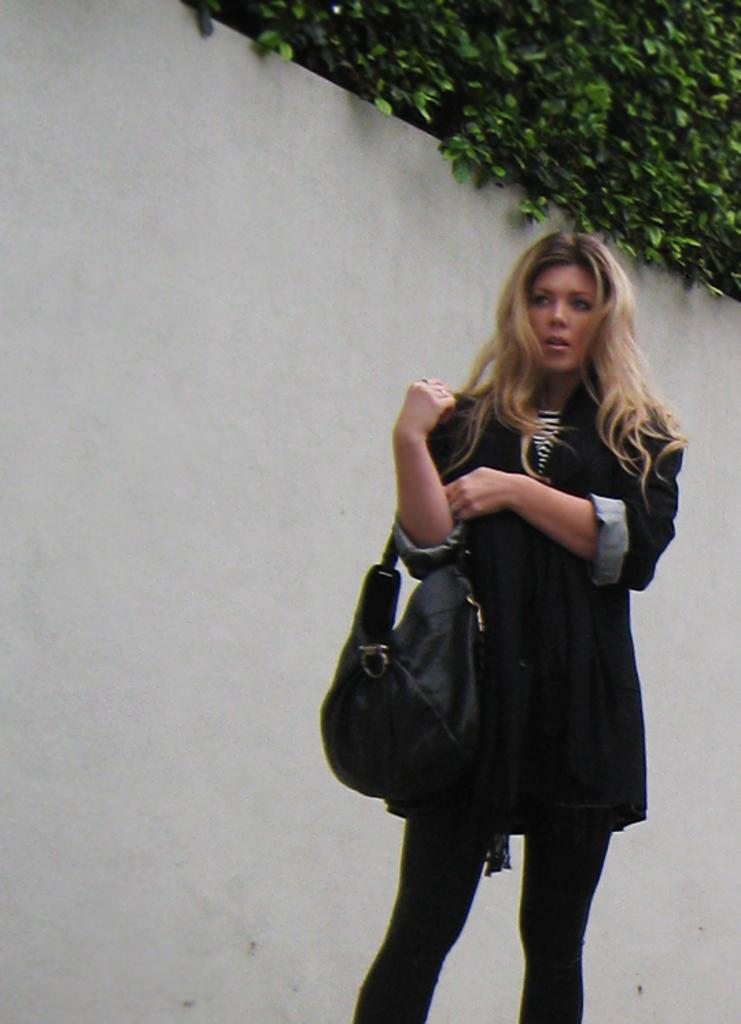What is the main subject of the image? The main subject of the image is a woman. What is the woman carrying in the image? The woman is carrying a bag in the image. How many passengers are visible in the image? There is no reference to passengers in the image, as it only features a woman carrying a bag. 